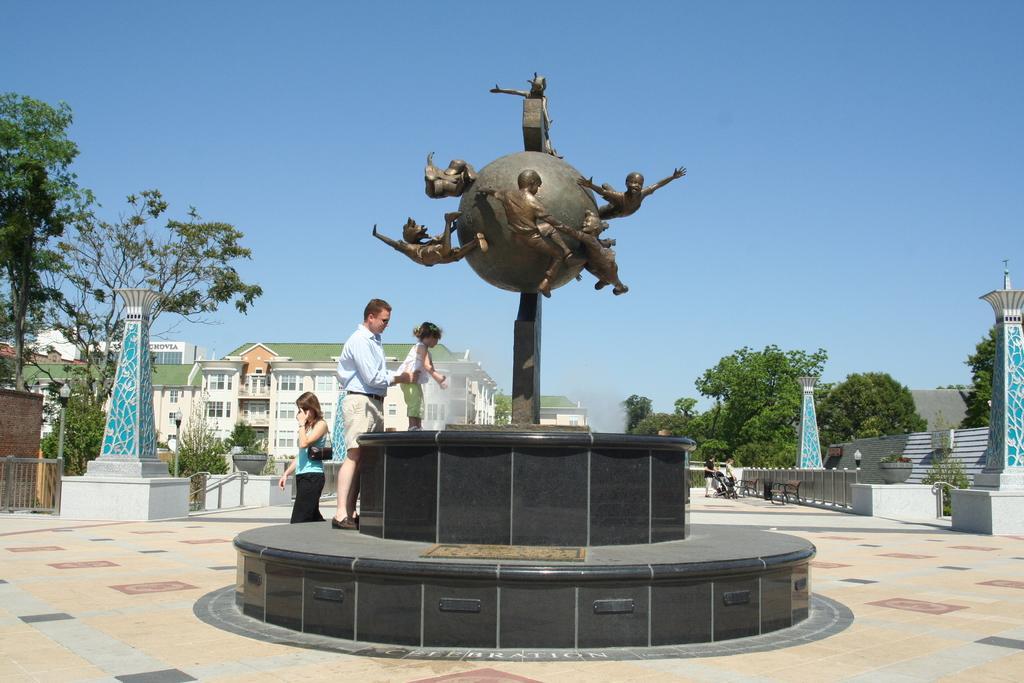Describe this image in one or two sentences. At the center of the image there is a statue, beside the statue there are a few people standing and there are few pillars, trees, buildings, railing and in the background there is the sky. 